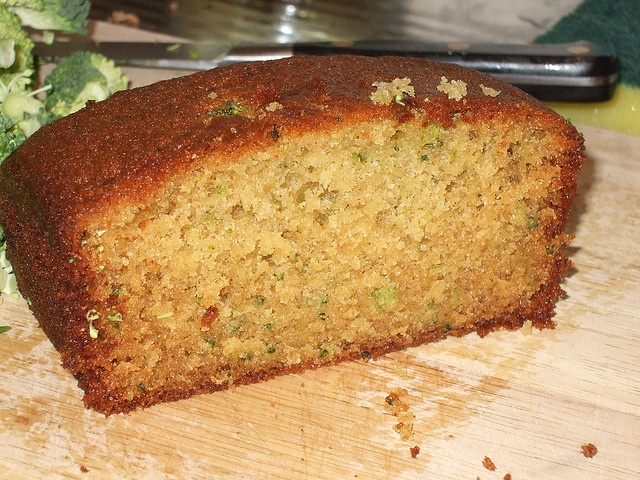Describe the objects in this image and their specific colors. I can see cake in khaki, tan, maroon, and brown tones, knife in khaki, black, gray, and darkgreen tones, broccoli in khaki, olive, and darkgreen tones, broccoli in khaki, green, and olive tones, and broccoli in khaki, tan, and olive tones in this image. 